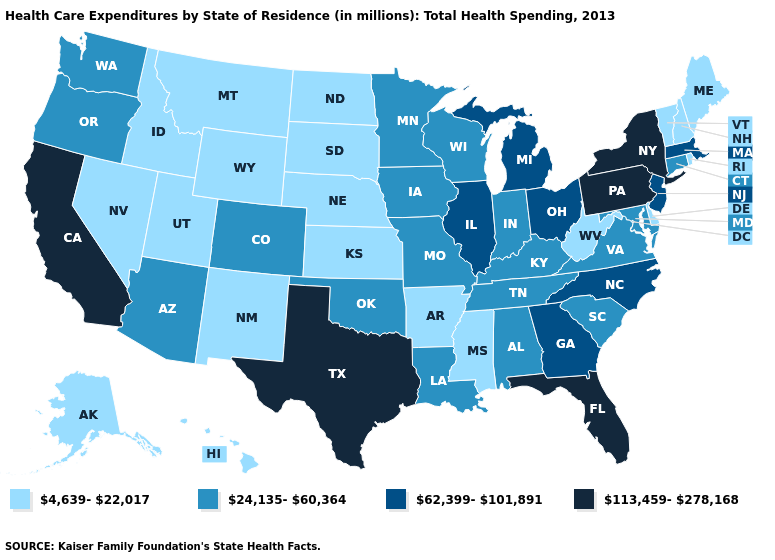What is the highest value in the Northeast ?
Short answer required. 113,459-278,168. Name the states that have a value in the range 113,459-278,168?
Keep it brief. California, Florida, New York, Pennsylvania, Texas. Among the states that border Oregon , does Washington have the highest value?
Be succinct. No. What is the value of Kansas?
Answer briefly. 4,639-22,017. What is the value of Indiana?
Write a very short answer. 24,135-60,364. What is the value of New Mexico?
Short answer required. 4,639-22,017. Name the states that have a value in the range 62,399-101,891?
Be succinct. Georgia, Illinois, Massachusetts, Michigan, New Jersey, North Carolina, Ohio. What is the highest value in the USA?
Write a very short answer. 113,459-278,168. How many symbols are there in the legend?
Give a very brief answer. 4. What is the highest value in the South ?
Keep it brief. 113,459-278,168. Does Ohio have a higher value than Maine?
Answer briefly. Yes. Among the states that border Arizona , which have the highest value?
Be succinct. California. Name the states that have a value in the range 62,399-101,891?
Short answer required. Georgia, Illinois, Massachusetts, Michigan, New Jersey, North Carolina, Ohio. What is the lowest value in the USA?
Concise answer only. 4,639-22,017. Name the states that have a value in the range 24,135-60,364?
Answer briefly. Alabama, Arizona, Colorado, Connecticut, Indiana, Iowa, Kentucky, Louisiana, Maryland, Minnesota, Missouri, Oklahoma, Oregon, South Carolina, Tennessee, Virginia, Washington, Wisconsin. 